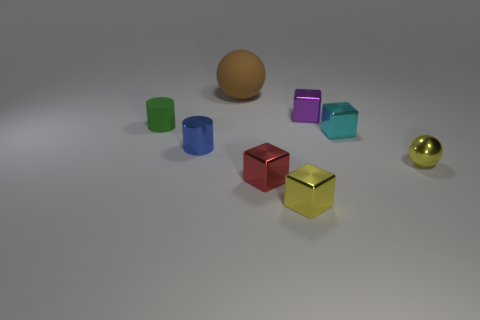Does the tiny matte cylinder have the same color as the metal cube behind the tiny rubber cylinder? No, they do not have the same color. The tiny matte cylinder appears to be green, while the metal cube behind the tiny rubber cylinder has a red color, displaying a noticeable contrast between the two objects. 